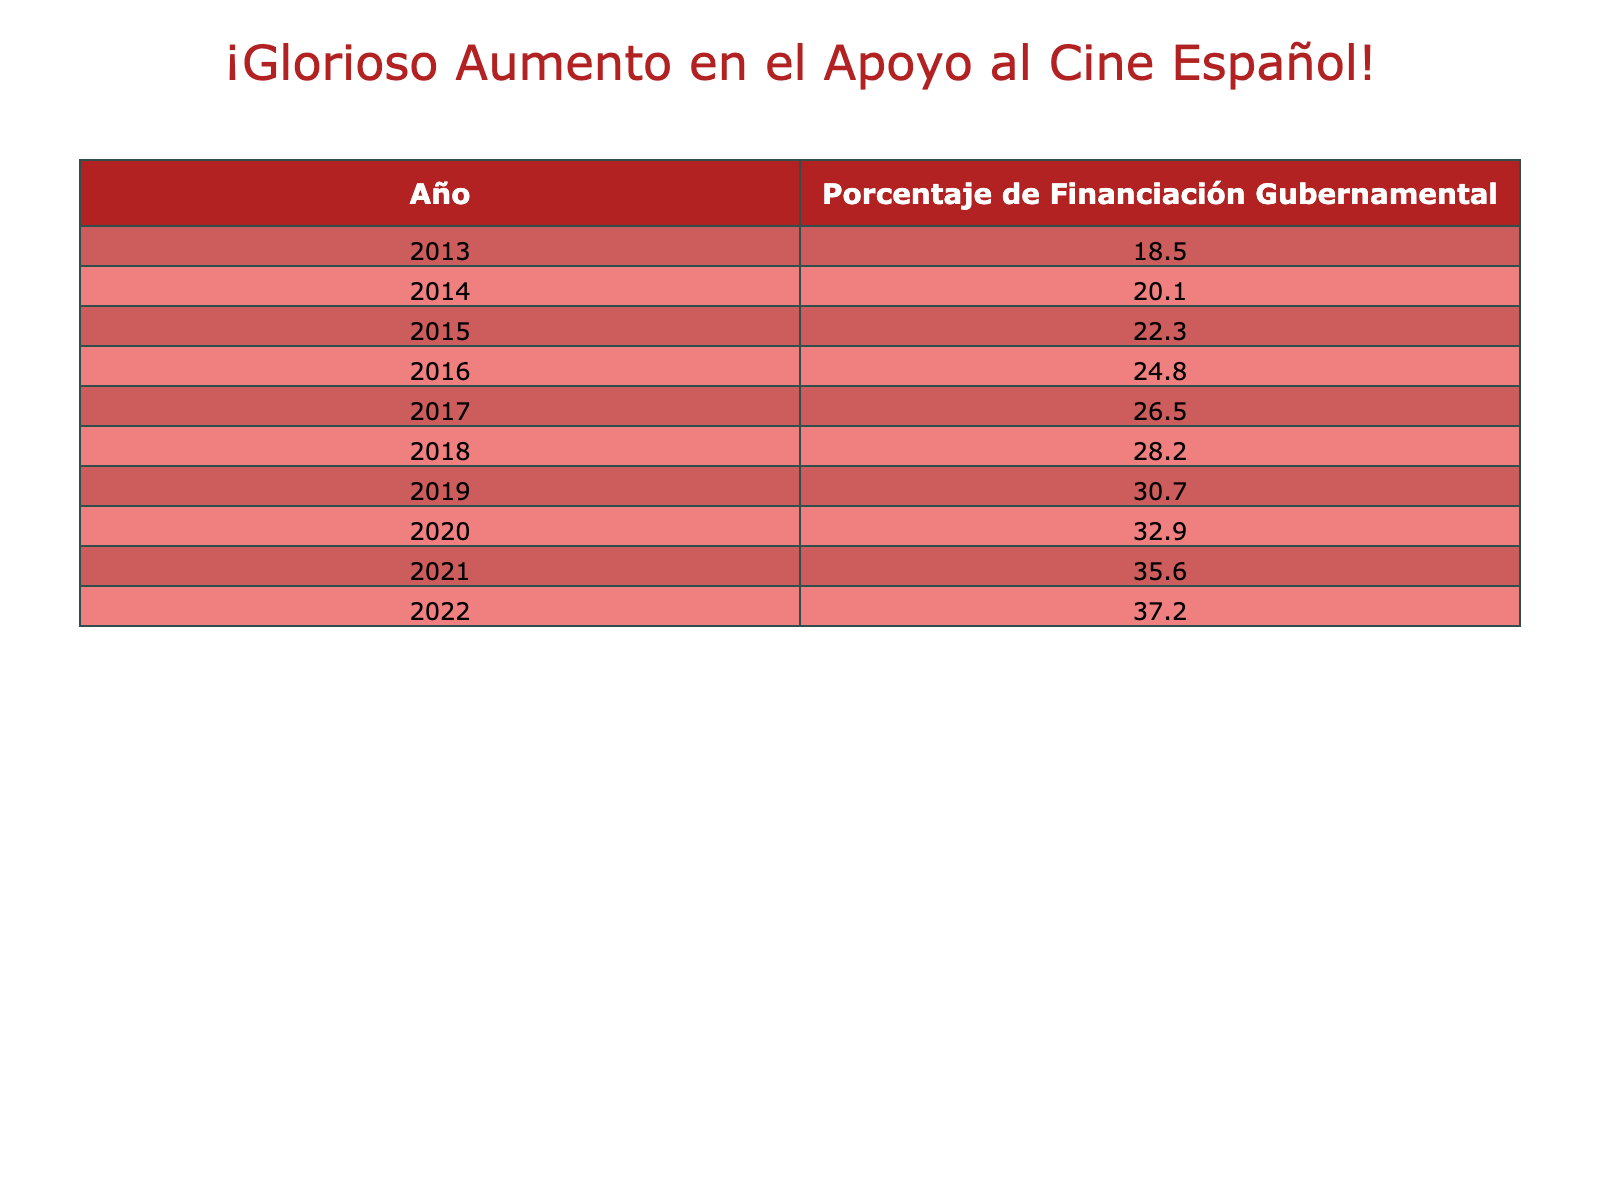What was the percentage of government funding for Spanish film productions in 2016? The table shows that in 2016, the percentage of government funding was specifically listed as 24.8%.
Answer: 24.8% Which year had the highest percentage of government funding? By examining the table, it's clear that the highest percentage of government funding occurred in 2022, where it reached 37.2%.
Answer: 37.2% What is the difference in government funding between 2013 and 2021? From the table, in 2013 the funding was 18.5% and in 2021 it was 35.6%. The difference is calculated as 35.6% - 18.5% = 17.1%.
Answer: 17.1% What was the average percentage of government funding from 2013 to 2019? To find the average, add the percentages from each year (18.5 + 20.1 + 22.3 + 24.8 + 26.5 + 30.7) which sums up to 142.9%. Then divide by the number of years, which is 7. So, 142.9% / 7 = 20.4%.
Answer: 20.4% Did the percentage of government funding increase every year from 2013 to 2022? By observing the table, it's evident that the percentage of government funding consistently increased year over year without any declines between 2013 and 2022.
Answer: Yes What was the percentage increase in government funding from 2014 to 2018? From the table, the funding in 2014 was 20.1% and in 2018 it was 28.2%. The increase is calculated as (28.2% - 20.1%) = 8.1%.
Answer: 8.1% How many years had government funding above 30%? Looking at the table, the years with funding above 30% are 2019 (30.7%), 2020 (32.9%), 2021 (35.6%), and 2022 (37.2%). This is a total of 4 years.
Answer: 4 years In which year did the government funding cross the 25% mark? From the table, government funding exceeded 25% for the first time in 2017 when it was at 26.5%.
Answer: 2017 What was the overall trend in government funding from 2013 to 2022? The table shows a consistent upward trend in government funding every year from 2013 to 2022, indicating a positive growth in support for Spanish film productions.
Answer: Increasing trend 